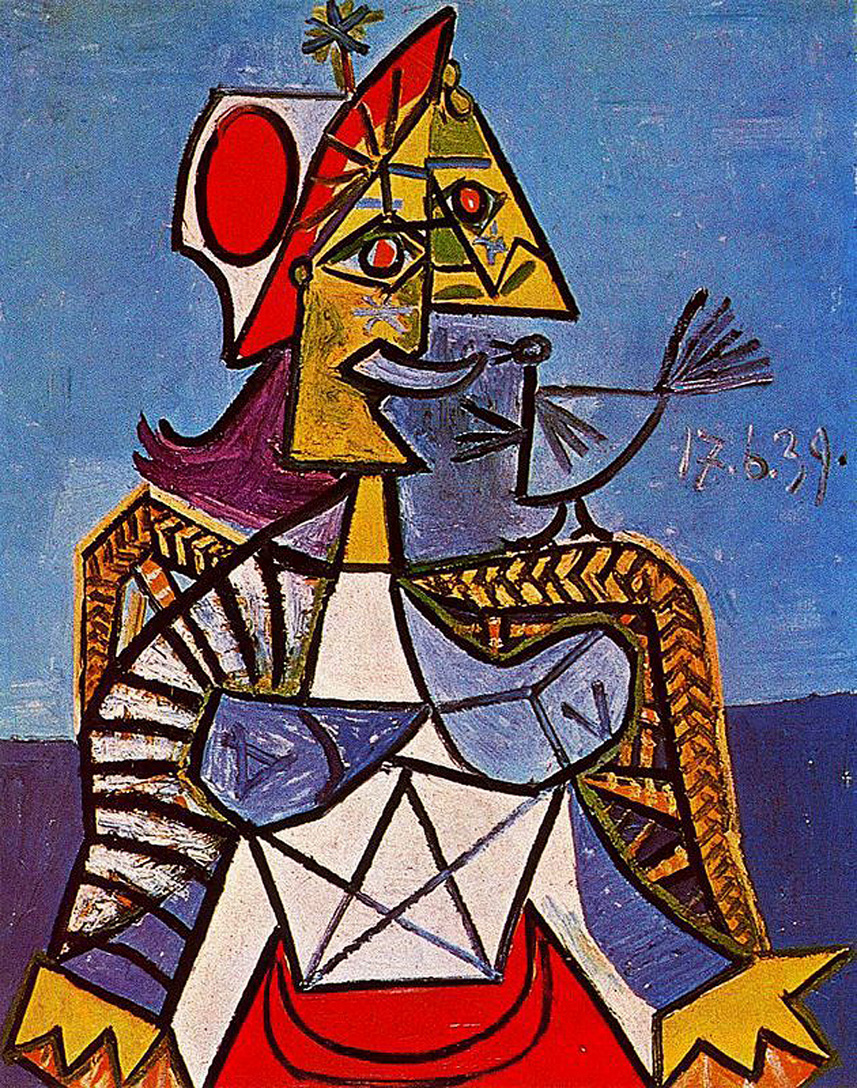What might the bird in the figure's hand represent in the context of this artwork? In the context of this Cubist artwork, the bird in the figure's hand could symbolize several things. Birds often represent freedom and transcendence, indicating that the figure might possess or desire these qualities. Given the crown on the figure's head, the bird might also suggest a connection between power and freedom, or it could symbolize the responsibility and care that come with authority. The bird's delicate and unique rendering adds to the artwork’s narrative, possibly hinting at a harmonious relationship between the natural world and constructed power structures. 